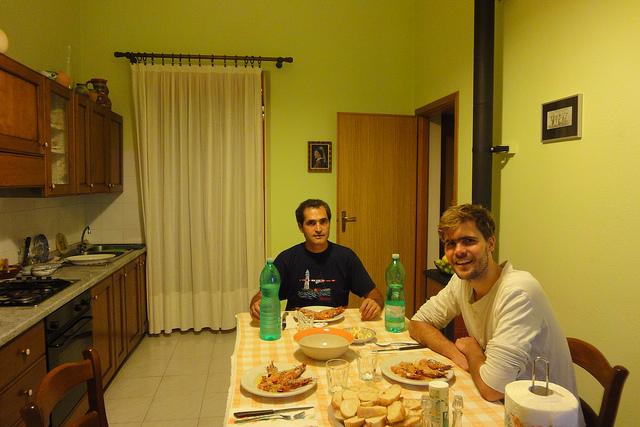How many bottles are on table?
Be succinct. 2. What is this man doing?
Write a very short answer. Eating. How many men are sitting at the table?
Write a very short answer. 2. How many people are in this picture?
Give a very brief answer. 2. What time of day is the picture taken in?
Concise answer only. Night. Where is the pterodactyl?
Keep it brief. Table. What color is the boys shirt?
Quick response, please. White. Is this a hotel restaurant?
Answer briefly. No. How many trays are on the table?
Give a very brief answer. 0. What color is the man's shirt?
Quick response, please. White. Is the tall bottle on the table almost full?
Short answer required. Yes. Is it daylight outside?
Give a very brief answer. No. What room in the house are the men sitting in?
Keep it brief. Kitchen. Are two people wearing similar patterns?
Keep it brief. No. Is this a restaurant?
Be succinct. No. How many beverages are on the table?
Answer briefly. 2. What type of food are people working with?
Answer briefly. Dinner. 